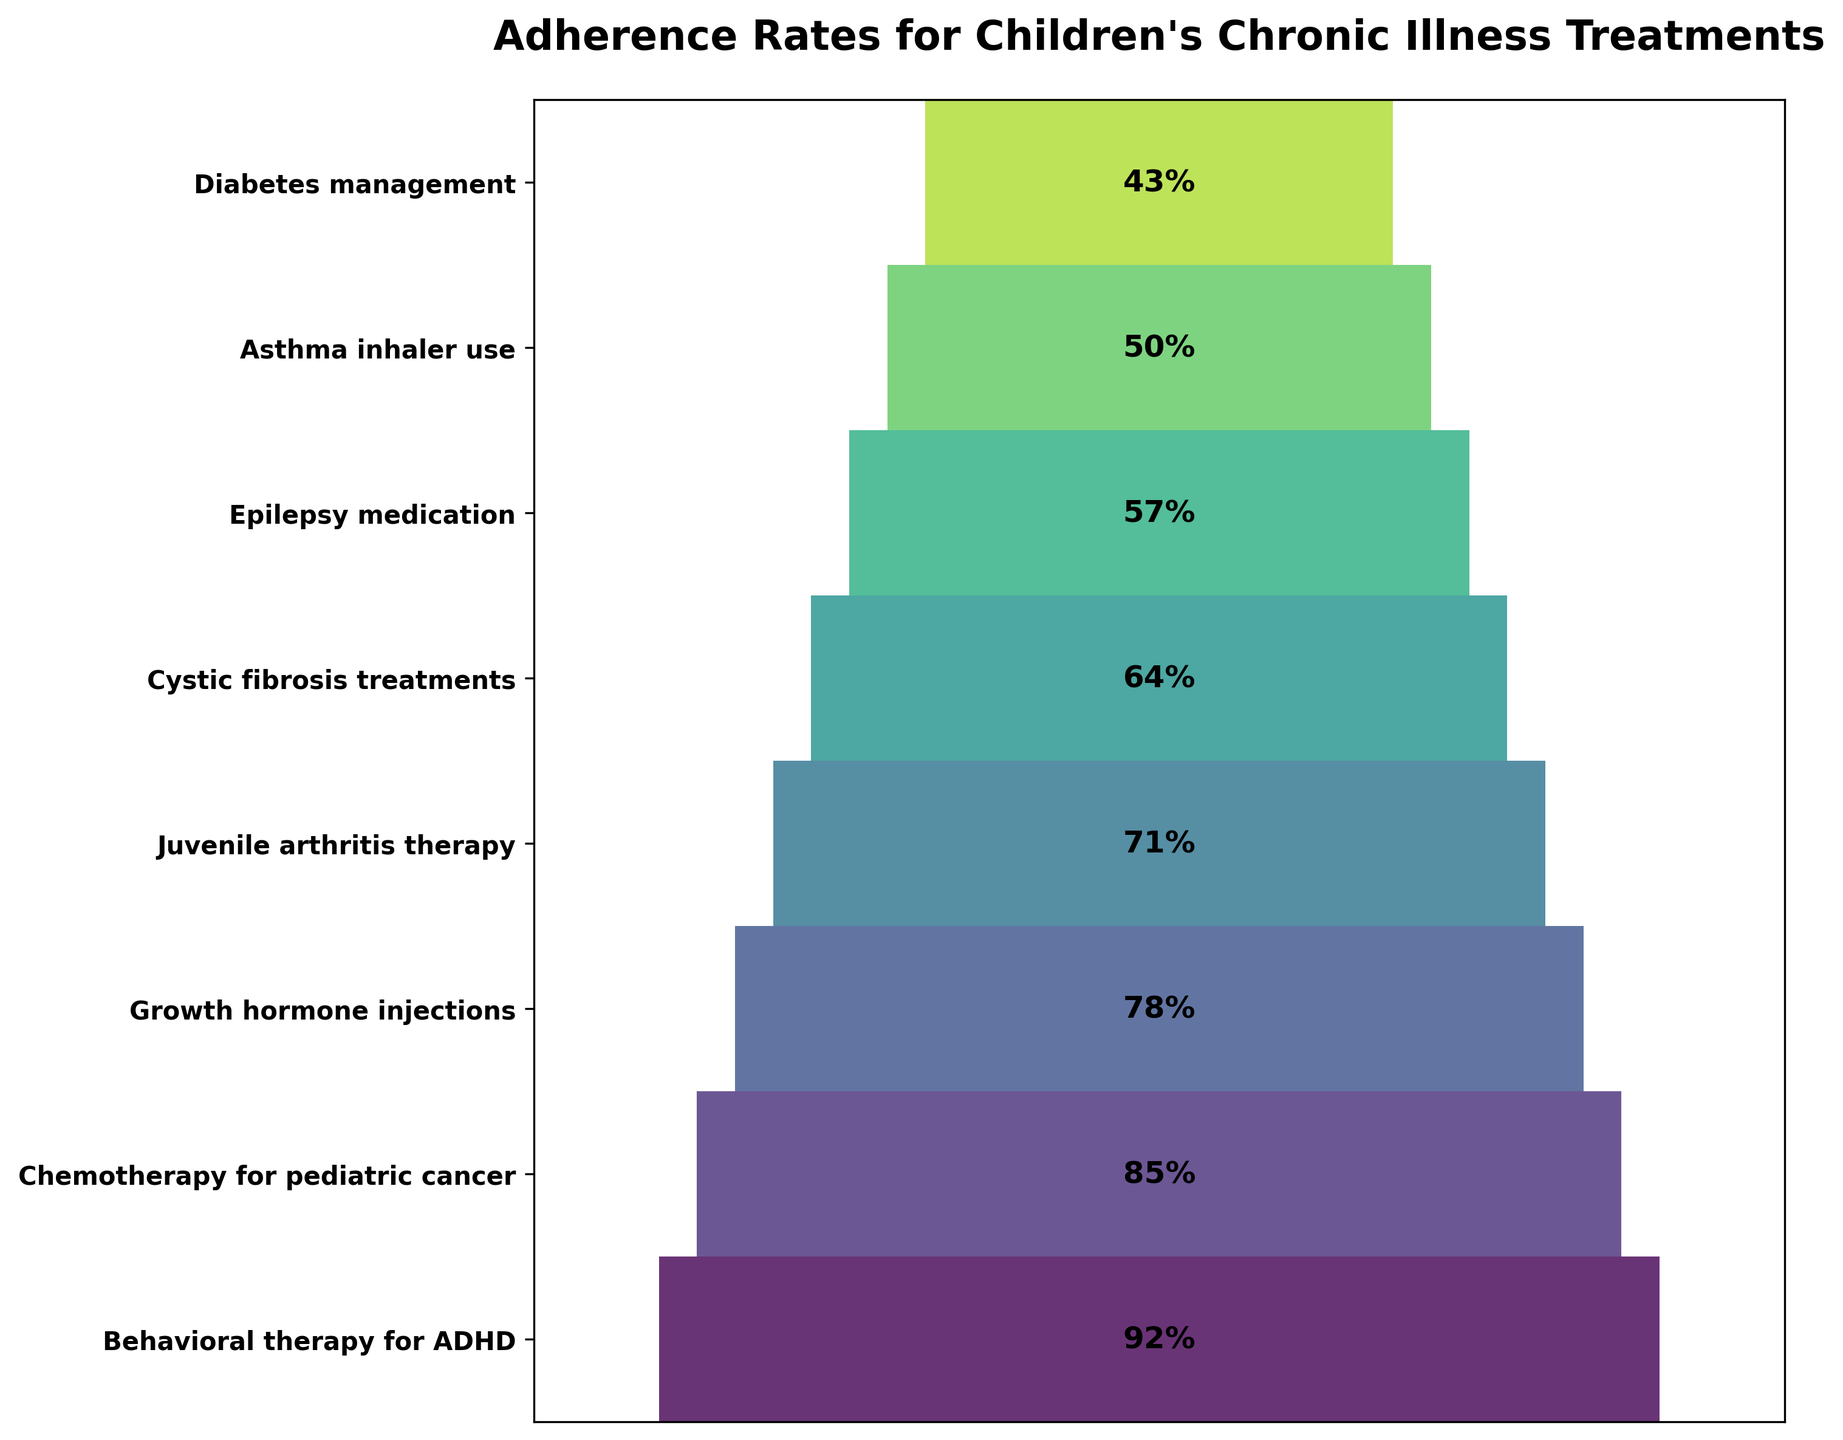Which treatment has the highest adherence rate? The treatment with the highest adherence rate will be at the top of the funnel chart. By looking at the topmost part of the chart, we can see that "Diabetes management" has the highest adherence rate.
Answer: Diabetes management How many treatment types are represented in the funnel chart? To determine the number of treatment types, we simply count the number of segments in the funnel chart. Each segment represents a different treatment type. There are 8 segments in total.
Answer: 8 What is the adherence rate for chemotherapy for pediatric cancer? Locate the segment for "Chemotherapy for pediatric cancer" on the funnel chart and check the percentage label. The adherence rate is 50%.
Answer: 50% Which treatment has a lower adherence rate: cystic fibrosis treatments or asthma inhaler use? By comparing the positions of the segments and their corresponding adherence rates in the funnel chart, we see that "Cystic fibrosis treatments" has an adherence rate of 71%, while "Asthma inhaler use" has an adherence rate of 85%. Thus, cystic fibrosis treatments have a lower adherence rate.
Answer: Cystic fibrosis treatments What is the adherence rate difference between growth hormone injections and juvenile arthritis therapy? Find the adherence rates for both "Growth hormone injections" (57%) and "Juvenile arthritis therapy" (64%), then subtract the smaller value from the larger value: 64% - 57% = 7%.
Answer: 7% What's the average adherence rate of the top three treatments in the chart? The top three treatments are "Diabetes management" (92%), "Asthma inhaler use" (85%), and "Epilepsy medication" (78%). Calculate the average: (92 + 85 + 78) / 3 = 255 / 3 = 85%.
Answer: 85% Which treatment has the least adherence rate? The treatment with the least adherence rate will be at the bottom of the funnel chart. By looking at the bottommost part of the chart, we can see that "Behavioral therapy for ADHD" has the least adherence rate.
Answer: Behavioral therapy for ADHD How many treatments have adherence rates above 70%? Look at the funnel chart and count the number of treatments with adherence rates greater than 70%. The treatments are "Diabetes management" (92%), "Asthma inhaler use" (85%), "Epilepsy medication" (78%), and "Cystic fibrosis treatments" (71%). Thus, there are 4 treatments above 70%.
Answer: 4 What is the median adherence rate? To find the median adherence rate, we need to order the rates from highest to lowest: 92%, 85%, 78%, 71%, 64%, 57%, 50%, 43%. The median is the middle value when the number of values is odd and the average of two middle values when it is even. For 8 values, the median is the average of the 4th and 5th values: (71 + 64) / 2 = 67.5%.
Answer: 67.5% 